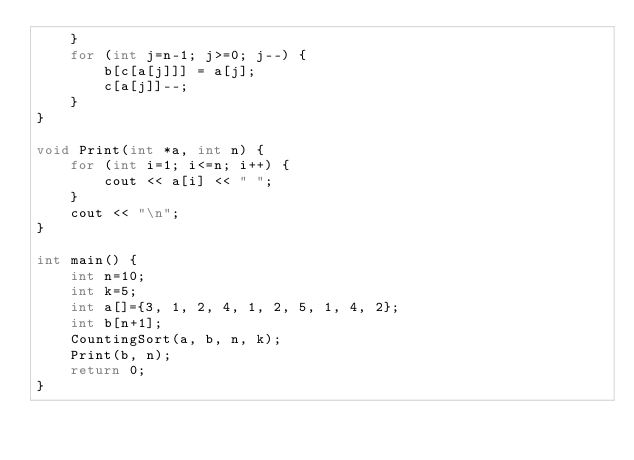Convert code to text. <code><loc_0><loc_0><loc_500><loc_500><_C++_>    }
    for (int j=n-1; j>=0; j--) {
        b[c[a[j]]] = a[j];
        c[a[j]]--;
    }
}

void Print(int *a, int n) {
    for (int i=1; i<=n; i++) {
        cout << a[i] << " ";
    }
    cout << "\n";
}

int main() {
    int n=10;
    int k=5;
    int a[]={3, 1, 2, 4, 1, 2, 5, 1, 4, 2};
    int b[n+1];
    CountingSort(a, b, n, k);
    Print(b, n);
    return 0;
}</code> 